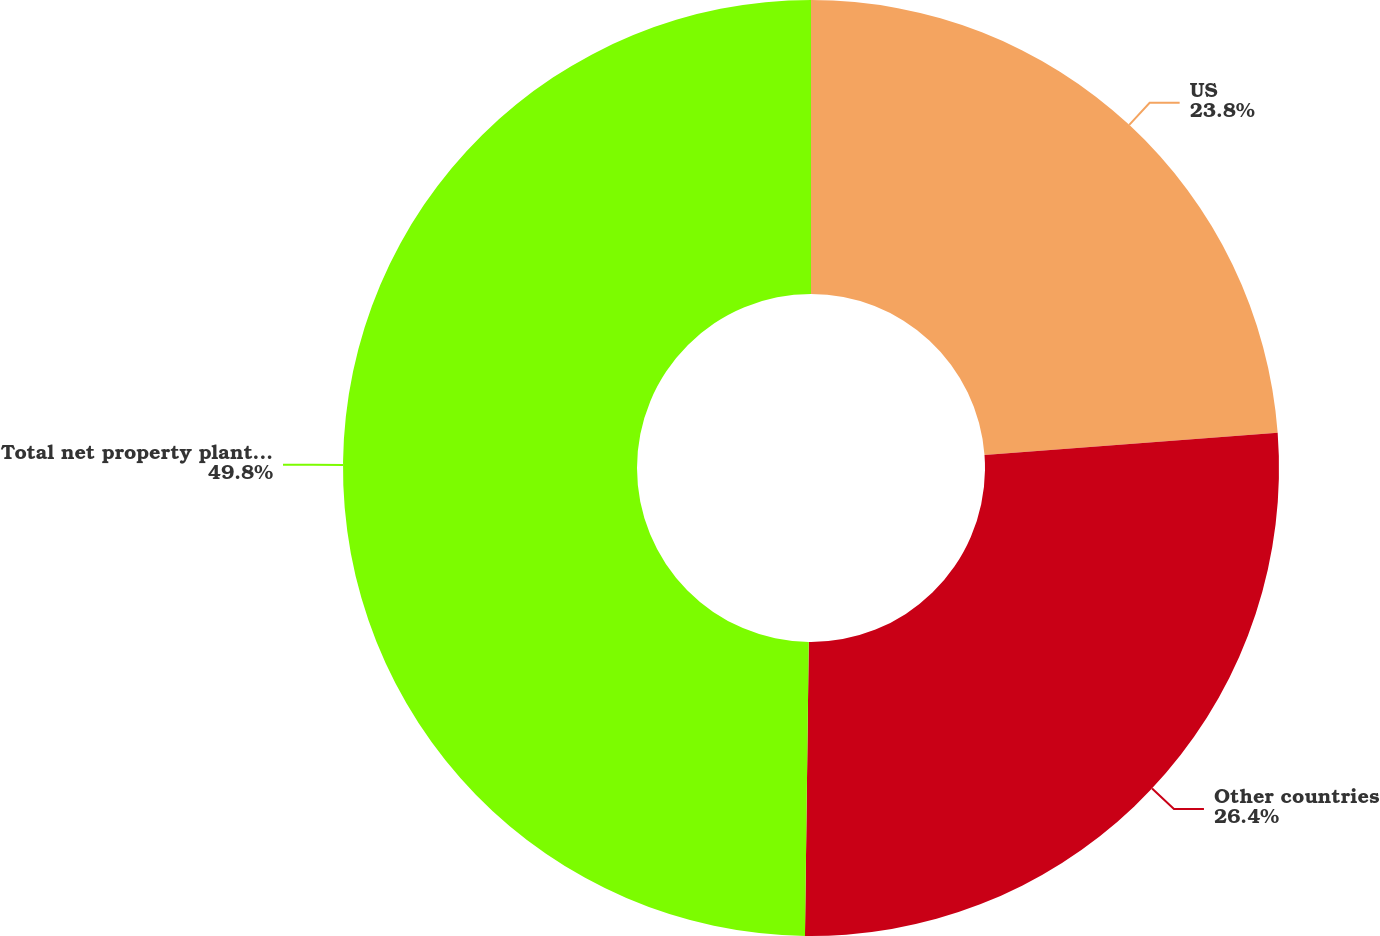<chart> <loc_0><loc_0><loc_500><loc_500><pie_chart><fcel>US<fcel>Other countries<fcel>Total net property plant and<nl><fcel>23.8%<fcel>26.4%<fcel>49.79%<nl></chart> 